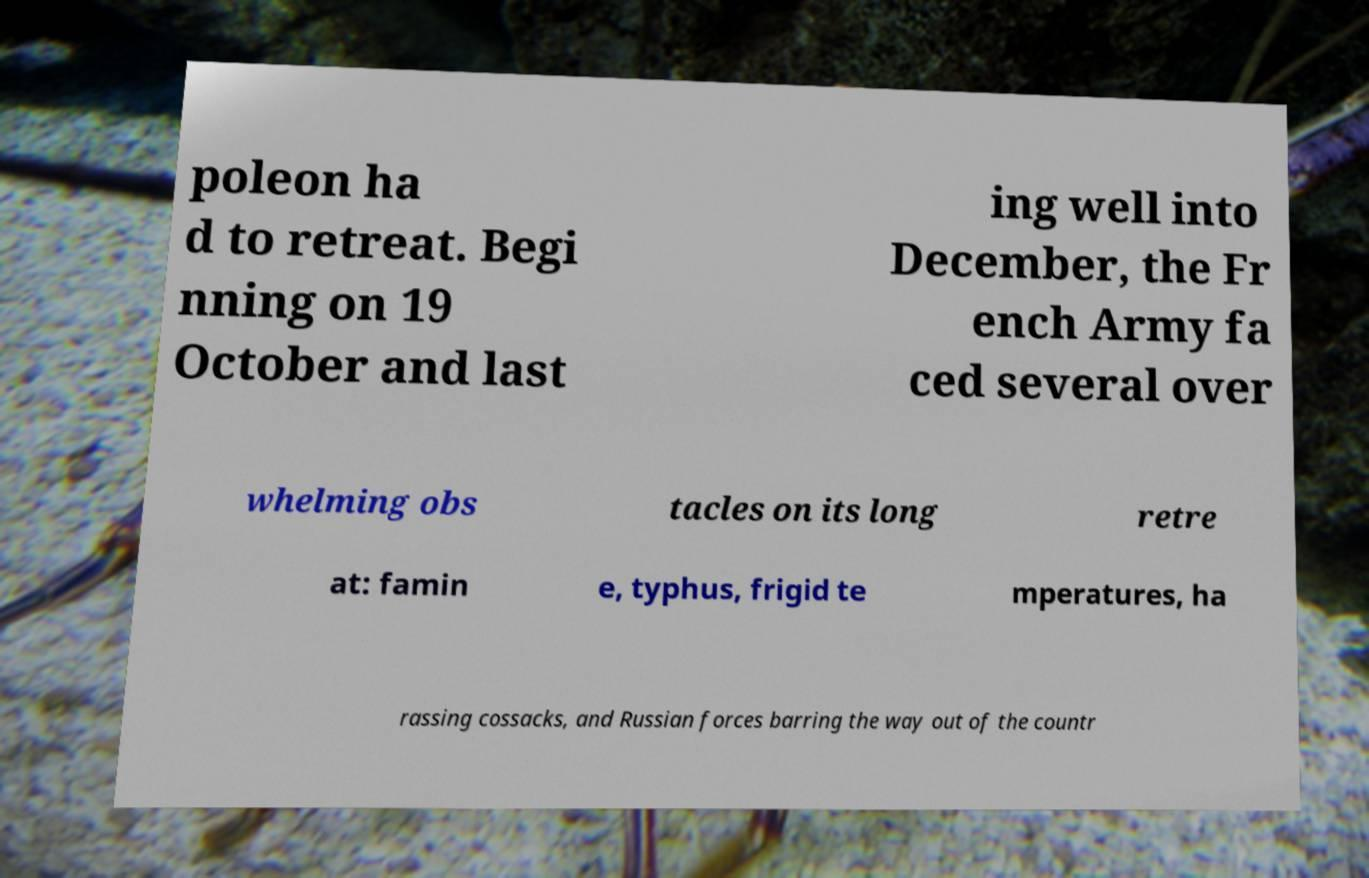What messages or text are displayed in this image? I need them in a readable, typed format. poleon ha d to retreat. Begi nning on 19 October and last ing well into December, the Fr ench Army fa ced several over whelming obs tacles on its long retre at: famin e, typhus, frigid te mperatures, ha rassing cossacks, and Russian forces barring the way out of the countr 